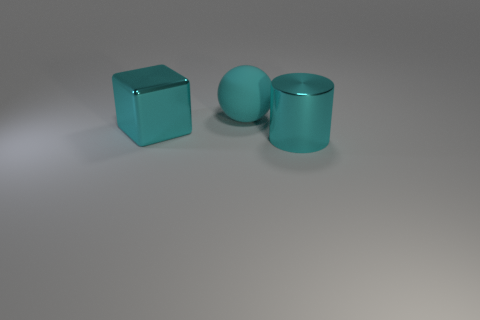There is a big cyan object that is left of the cyan cylinder and to the right of the large shiny cube; what is it made of? Based on the appearance of the object which has a smooth surface with a slight reflection and lacks any textural details suggesting other natural materials, it can be inferred that the big cyan object, possibly a sphere, is likely made of a synthetic material such as plastic or a similarly rendered digital material in a virtual simulation. 